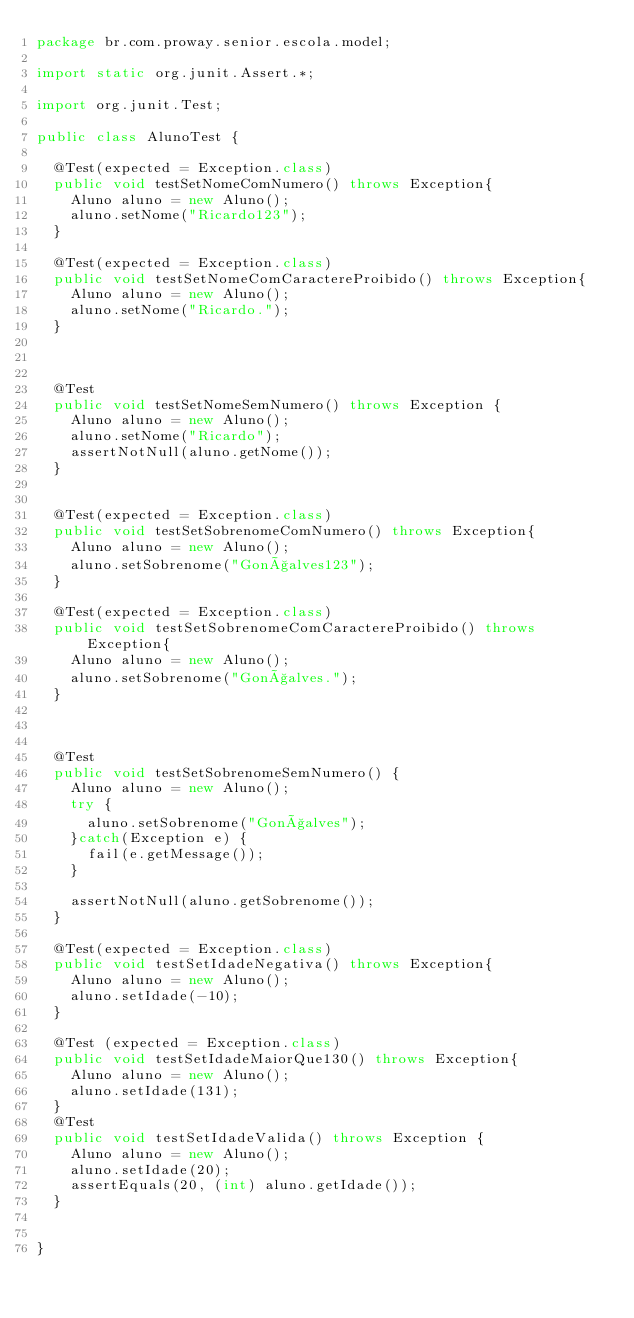Convert code to text. <code><loc_0><loc_0><loc_500><loc_500><_Java_>package br.com.proway.senior.escola.model;

import static org.junit.Assert.*;

import org.junit.Test;

public class AlunoTest {

	@Test(expected = Exception.class)
	public void testSetNomeComNumero() throws Exception{
		Aluno aluno = new Aluno();
		aluno.setNome("Ricardo123");
	}

	@Test(expected = Exception.class)
	public void testSetNomeComCaractereProibido() throws Exception{
		Aluno aluno = new Aluno();
		aluno.setNome("Ricardo.");
	}
	

	
	@Test
	public void testSetNomeSemNumero() throws Exception {
		Aluno aluno = new Aluno();
		aluno.setNome("Ricardo");	
		assertNotNull(aluno.getNome());
	}
	
	
	@Test(expected = Exception.class)
	public void testSetSobrenomeComNumero() throws Exception{
		Aluno aluno = new Aluno();
		aluno.setSobrenome("Gonçalves123");
	}

	@Test(expected = Exception.class)
	public void testSetSobrenomeComCaractereProibido() throws Exception{
		Aluno aluno = new Aluno();
		aluno.setSobrenome("Gonçalves.");
	}
	

	
	@Test
	public void testSetSobrenomeSemNumero() {
		Aluno aluno = new Aluno();
		try {
			aluno.setSobrenome("Gonçalves");	
		}catch(Exception e) {
			fail(e.getMessage());
		}
		
		assertNotNull(aluno.getSobrenome());
	}
	
	@Test(expected = Exception.class)
	public void testSetIdadeNegativa() throws Exception{
		Aluno aluno = new Aluno();
		aluno.setIdade(-10);
	}
	
	@Test (expected = Exception.class)
	public void testSetIdadeMaiorQue130() throws Exception{
		Aluno aluno = new Aluno();
		aluno.setIdade(131);
	}
	@Test 
	public void testSetIdadeValida() throws Exception {
		Aluno aluno = new Aluno();
		aluno.setIdade(20);
		assertEquals(20, (int) aluno.getIdade());
	}
	

}
</code> 